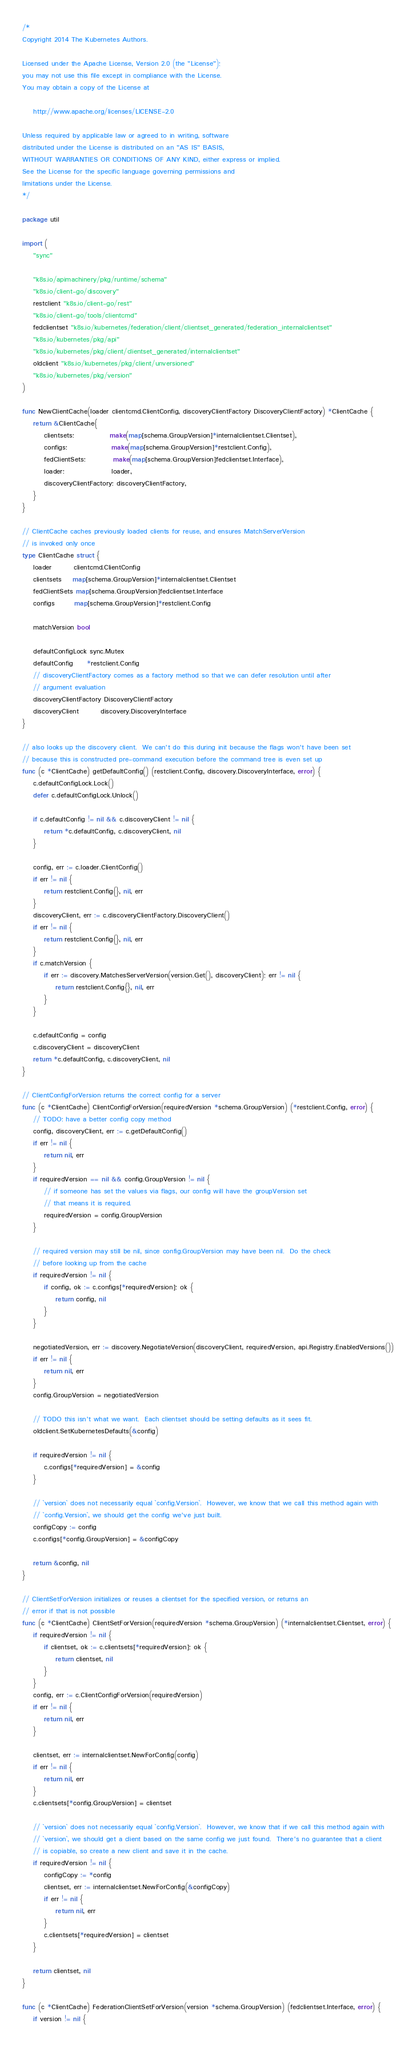Convert code to text. <code><loc_0><loc_0><loc_500><loc_500><_Go_>/*
Copyright 2014 The Kubernetes Authors.

Licensed under the Apache License, Version 2.0 (the "License");
you may not use this file except in compliance with the License.
You may obtain a copy of the License at

    http://www.apache.org/licenses/LICENSE-2.0

Unless required by applicable law or agreed to in writing, software
distributed under the License is distributed on an "AS IS" BASIS,
WITHOUT WARRANTIES OR CONDITIONS OF ANY KIND, either express or implied.
See the License for the specific language governing permissions and
limitations under the License.
*/

package util

import (
	"sync"

	"k8s.io/apimachinery/pkg/runtime/schema"
	"k8s.io/client-go/discovery"
	restclient "k8s.io/client-go/rest"
	"k8s.io/client-go/tools/clientcmd"
	fedclientset "k8s.io/kubernetes/federation/client/clientset_generated/federation_internalclientset"
	"k8s.io/kubernetes/pkg/api"
	"k8s.io/kubernetes/pkg/client/clientset_generated/internalclientset"
	oldclient "k8s.io/kubernetes/pkg/client/unversioned"
	"k8s.io/kubernetes/pkg/version"
)

func NewClientCache(loader clientcmd.ClientConfig, discoveryClientFactory DiscoveryClientFactory) *ClientCache {
	return &ClientCache{
		clientsets:             make(map[schema.GroupVersion]*internalclientset.Clientset),
		configs:                make(map[schema.GroupVersion]*restclient.Config),
		fedClientSets:          make(map[schema.GroupVersion]fedclientset.Interface),
		loader:                 loader,
		discoveryClientFactory: discoveryClientFactory,
	}
}

// ClientCache caches previously loaded clients for reuse, and ensures MatchServerVersion
// is invoked only once
type ClientCache struct {
	loader        clientcmd.ClientConfig
	clientsets    map[schema.GroupVersion]*internalclientset.Clientset
	fedClientSets map[schema.GroupVersion]fedclientset.Interface
	configs       map[schema.GroupVersion]*restclient.Config

	matchVersion bool

	defaultConfigLock sync.Mutex
	defaultConfig     *restclient.Config
	// discoveryClientFactory comes as a factory method so that we can defer resolution until after
	// argument evaluation
	discoveryClientFactory DiscoveryClientFactory
	discoveryClient        discovery.DiscoveryInterface
}

// also looks up the discovery client.  We can't do this during init because the flags won't have been set
// because this is constructed pre-command execution before the command tree is even set up
func (c *ClientCache) getDefaultConfig() (restclient.Config, discovery.DiscoveryInterface, error) {
	c.defaultConfigLock.Lock()
	defer c.defaultConfigLock.Unlock()

	if c.defaultConfig != nil && c.discoveryClient != nil {
		return *c.defaultConfig, c.discoveryClient, nil
	}

	config, err := c.loader.ClientConfig()
	if err != nil {
		return restclient.Config{}, nil, err
	}
	discoveryClient, err := c.discoveryClientFactory.DiscoveryClient()
	if err != nil {
		return restclient.Config{}, nil, err
	}
	if c.matchVersion {
		if err := discovery.MatchesServerVersion(version.Get(), discoveryClient); err != nil {
			return restclient.Config{}, nil, err
		}
	}

	c.defaultConfig = config
	c.discoveryClient = discoveryClient
	return *c.defaultConfig, c.discoveryClient, nil
}

// ClientConfigForVersion returns the correct config for a server
func (c *ClientCache) ClientConfigForVersion(requiredVersion *schema.GroupVersion) (*restclient.Config, error) {
	// TODO: have a better config copy method
	config, discoveryClient, err := c.getDefaultConfig()
	if err != nil {
		return nil, err
	}
	if requiredVersion == nil && config.GroupVersion != nil {
		// if someone has set the values via flags, our config will have the groupVersion set
		// that means it is required.
		requiredVersion = config.GroupVersion
	}

	// required version may still be nil, since config.GroupVersion may have been nil.  Do the check
	// before looking up from the cache
	if requiredVersion != nil {
		if config, ok := c.configs[*requiredVersion]; ok {
			return config, nil
		}
	}

	negotiatedVersion, err := discovery.NegotiateVersion(discoveryClient, requiredVersion, api.Registry.EnabledVersions())
	if err != nil {
		return nil, err
	}
	config.GroupVersion = negotiatedVersion

	// TODO this isn't what we want.  Each clientset should be setting defaults as it sees fit.
	oldclient.SetKubernetesDefaults(&config)

	if requiredVersion != nil {
		c.configs[*requiredVersion] = &config
	}

	// `version` does not necessarily equal `config.Version`.  However, we know that we call this method again with
	// `config.Version`, we should get the config we've just built.
	configCopy := config
	c.configs[*config.GroupVersion] = &configCopy

	return &config, nil
}

// ClientSetForVersion initializes or reuses a clientset for the specified version, or returns an
// error if that is not possible
func (c *ClientCache) ClientSetForVersion(requiredVersion *schema.GroupVersion) (*internalclientset.Clientset, error) {
	if requiredVersion != nil {
		if clientset, ok := c.clientsets[*requiredVersion]; ok {
			return clientset, nil
		}
	}
	config, err := c.ClientConfigForVersion(requiredVersion)
	if err != nil {
		return nil, err
	}

	clientset, err := internalclientset.NewForConfig(config)
	if err != nil {
		return nil, err
	}
	c.clientsets[*config.GroupVersion] = clientset

	// `version` does not necessarily equal `config.Version`.  However, we know that if we call this method again with
	// `version`, we should get a client based on the same config we just found.  There's no guarantee that a client
	// is copiable, so create a new client and save it in the cache.
	if requiredVersion != nil {
		configCopy := *config
		clientset, err := internalclientset.NewForConfig(&configCopy)
		if err != nil {
			return nil, err
		}
		c.clientsets[*requiredVersion] = clientset
	}

	return clientset, nil
}

func (c *ClientCache) FederationClientSetForVersion(version *schema.GroupVersion) (fedclientset.Interface, error) {
	if version != nil {</code> 